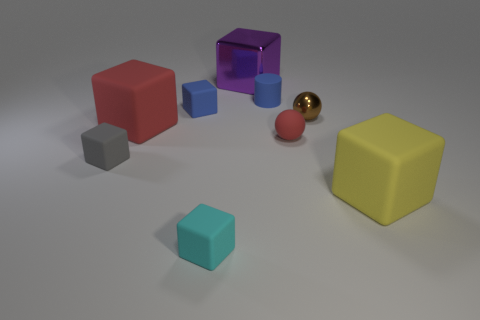There is another big object that is made of the same material as the large yellow object; what is its shape?
Your answer should be compact. Cube. There is a cylinder that is the same size as the red matte sphere; what is its color?
Keep it short and to the point. Blue. Is the size of the matte block that is right of the brown object the same as the big purple block?
Your answer should be compact. Yes. What number of big purple metal cylinders are there?
Make the answer very short. 0. What number of cubes are either purple shiny objects or blue matte things?
Provide a succinct answer. 2. There is a tiny blue object that is on the right side of the purple metallic cube; how many tiny brown spheres are on the right side of it?
Provide a succinct answer. 1. Are the yellow object and the cylinder made of the same material?
Make the answer very short. Yes. What size is the thing that is the same color as the cylinder?
Your answer should be very brief. Small. Are there any cubes that have the same material as the small brown sphere?
Provide a short and direct response. Yes. What color is the small matte cube in front of the large matte thing that is on the right side of the big matte cube on the left side of the big shiny cube?
Give a very brief answer. Cyan. 